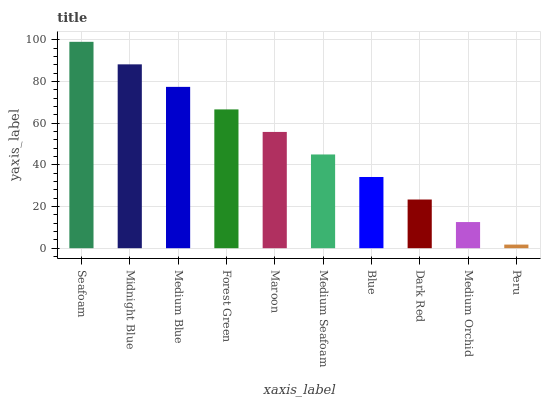Is Peru the minimum?
Answer yes or no. Yes. Is Seafoam the maximum?
Answer yes or no. Yes. Is Midnight Blue the minimum?
Answer yes or no. No. Is Midnight Blue the maximum?
Answer yes or no. No. Is Seafoam greater than Midnight Blue?
Answer yes or no. Yes. Is Midnight Blue less than Seafoam?
Answer yes or no. Yes. Is Midnight Blue greater than Seafoam?
Answer yes or no. No. Is Seafoam less than Midnight Blue?
Answer yes or no. No. Is Maroon the high median?
Answer yes or no. Yes. Is Medium Seafoam the low median?
Answer yes or no. Yes. Is Medium Orchid the high median?
Answer yes or no. No. Is Blue the low median?
Answer yes or no. No. 